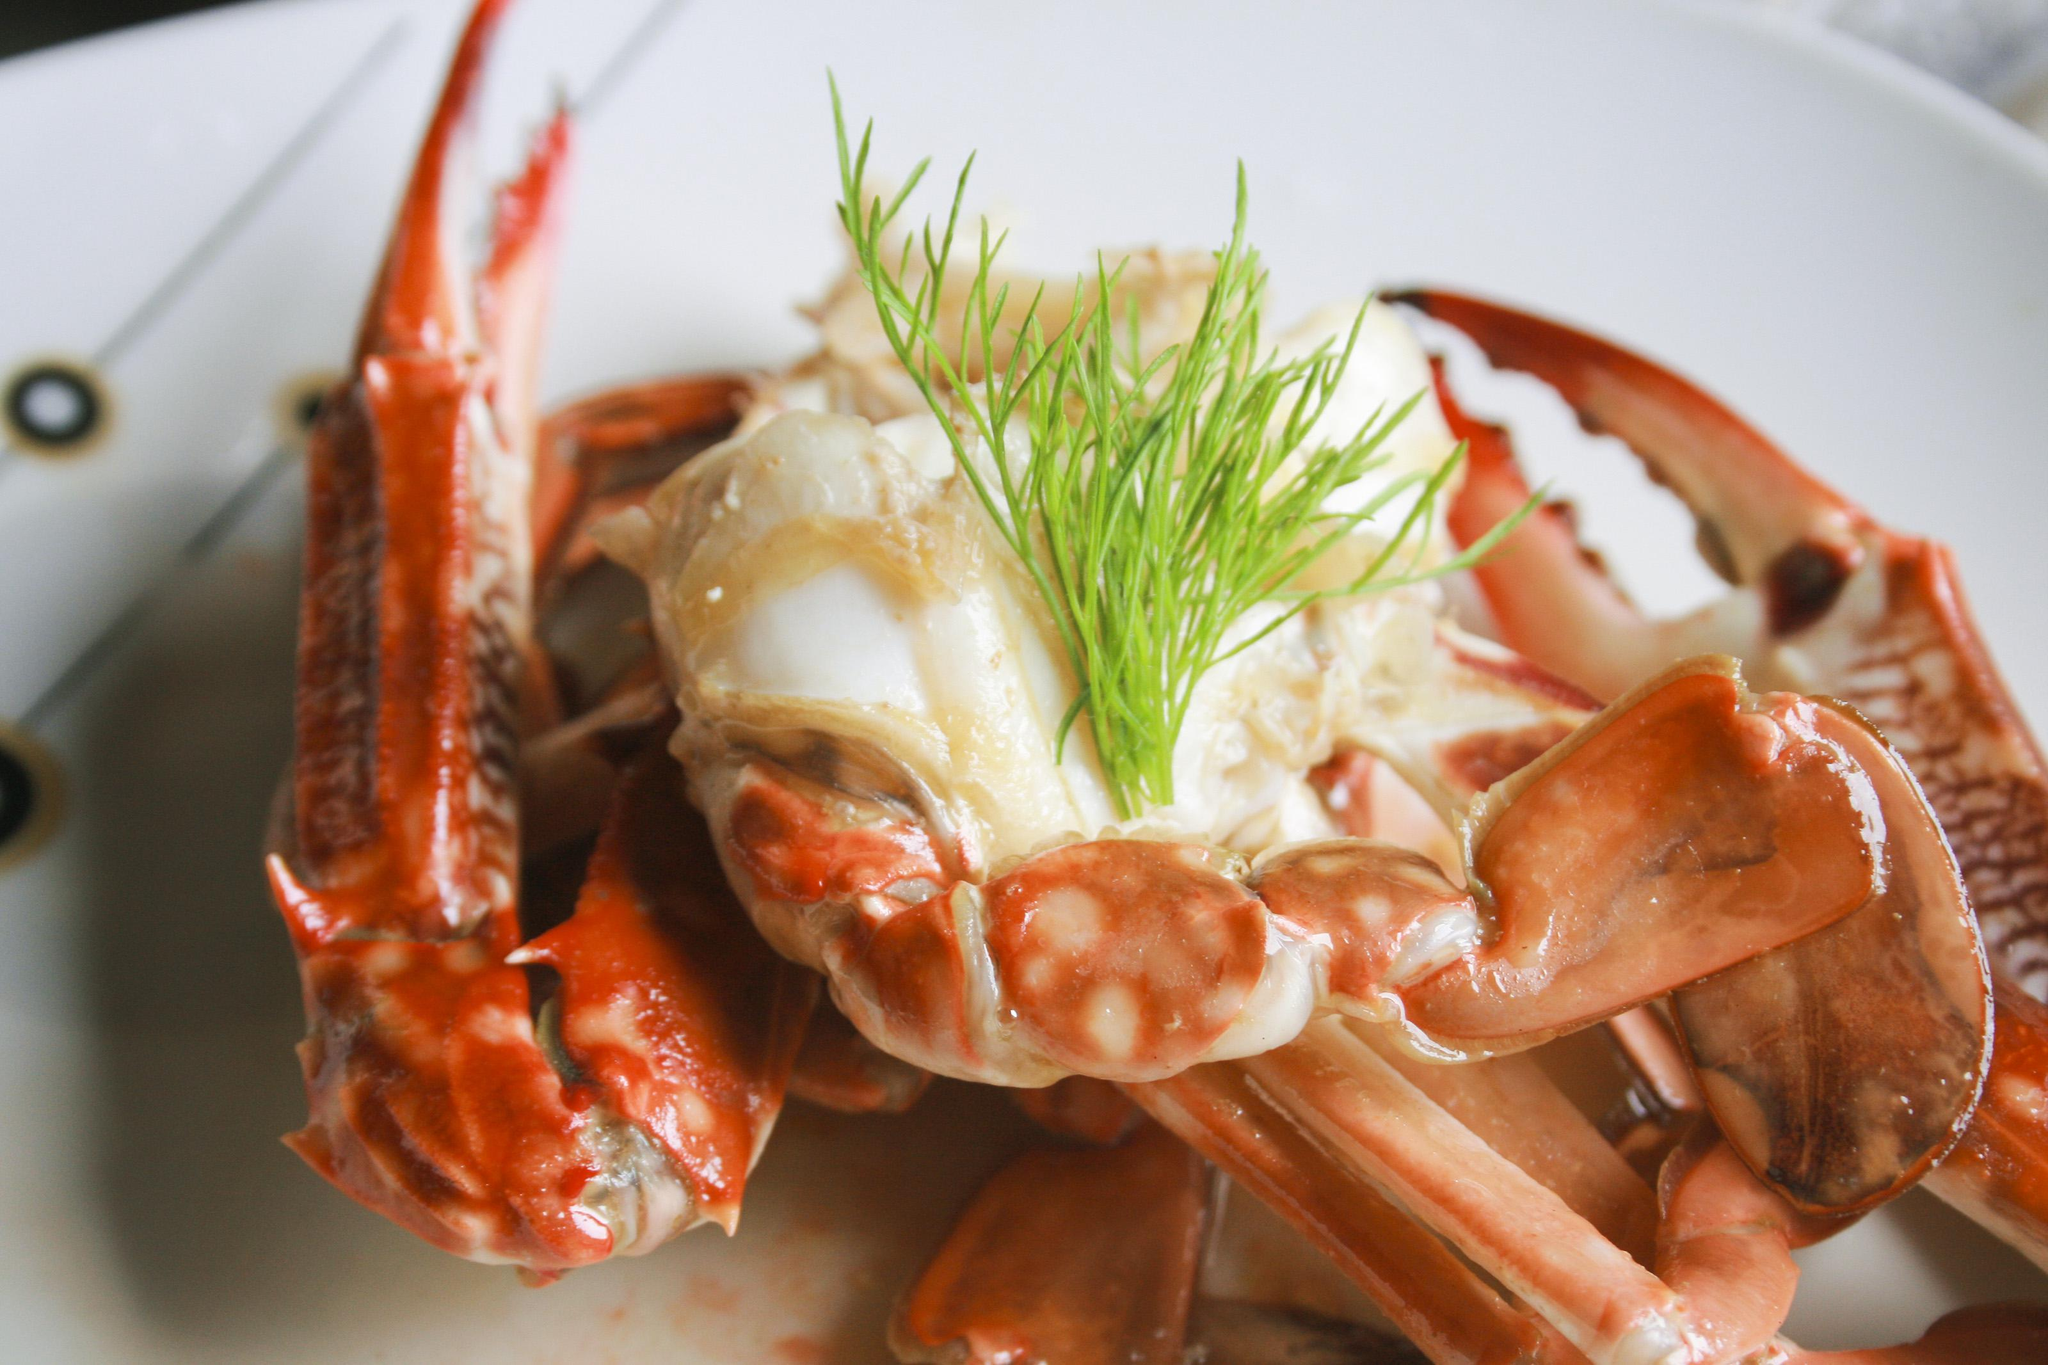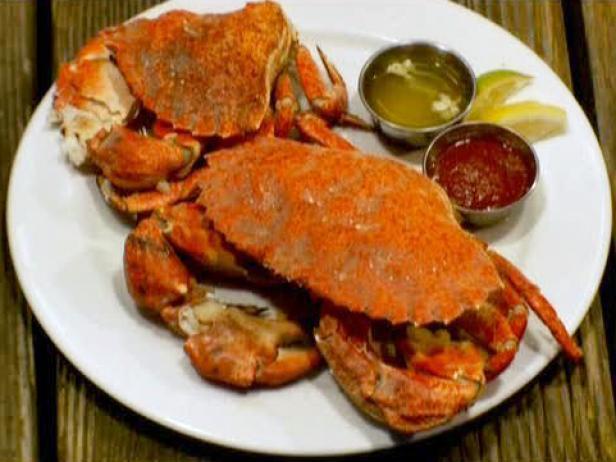The first image is the image on the left, the second image is the image on the right. Assess this claim about the two images: "There are crab legs separated from the body.". Correct or not? Answer yes or no. Yes. 